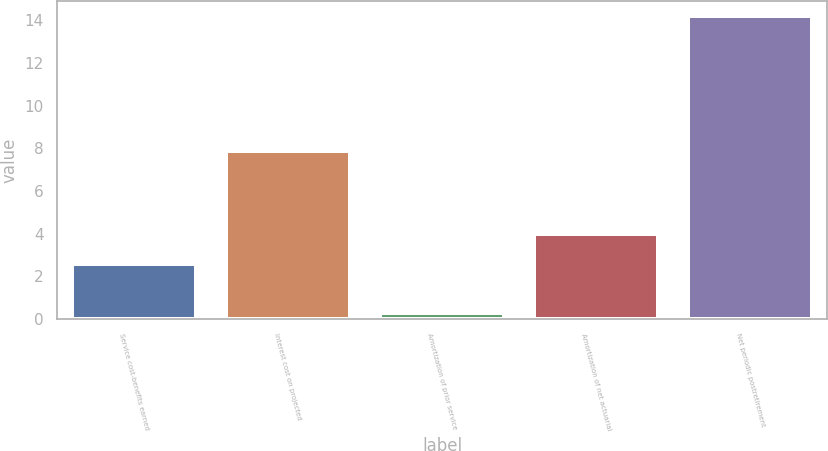<chart> <loc_0><loc_0><loc_500><loc_500><bar_chart><fcel>Service cost-benefits earned<fcel>Interest cost on projected<fcel>Amortization of prior service<fcel>Amortization of net actuarial<fcel>Net periodic postretirement<nl><fcel>2.6<fcel>7.9<fcel>0.3<fcel>3.99<fcel>14.2<nl></chart> 